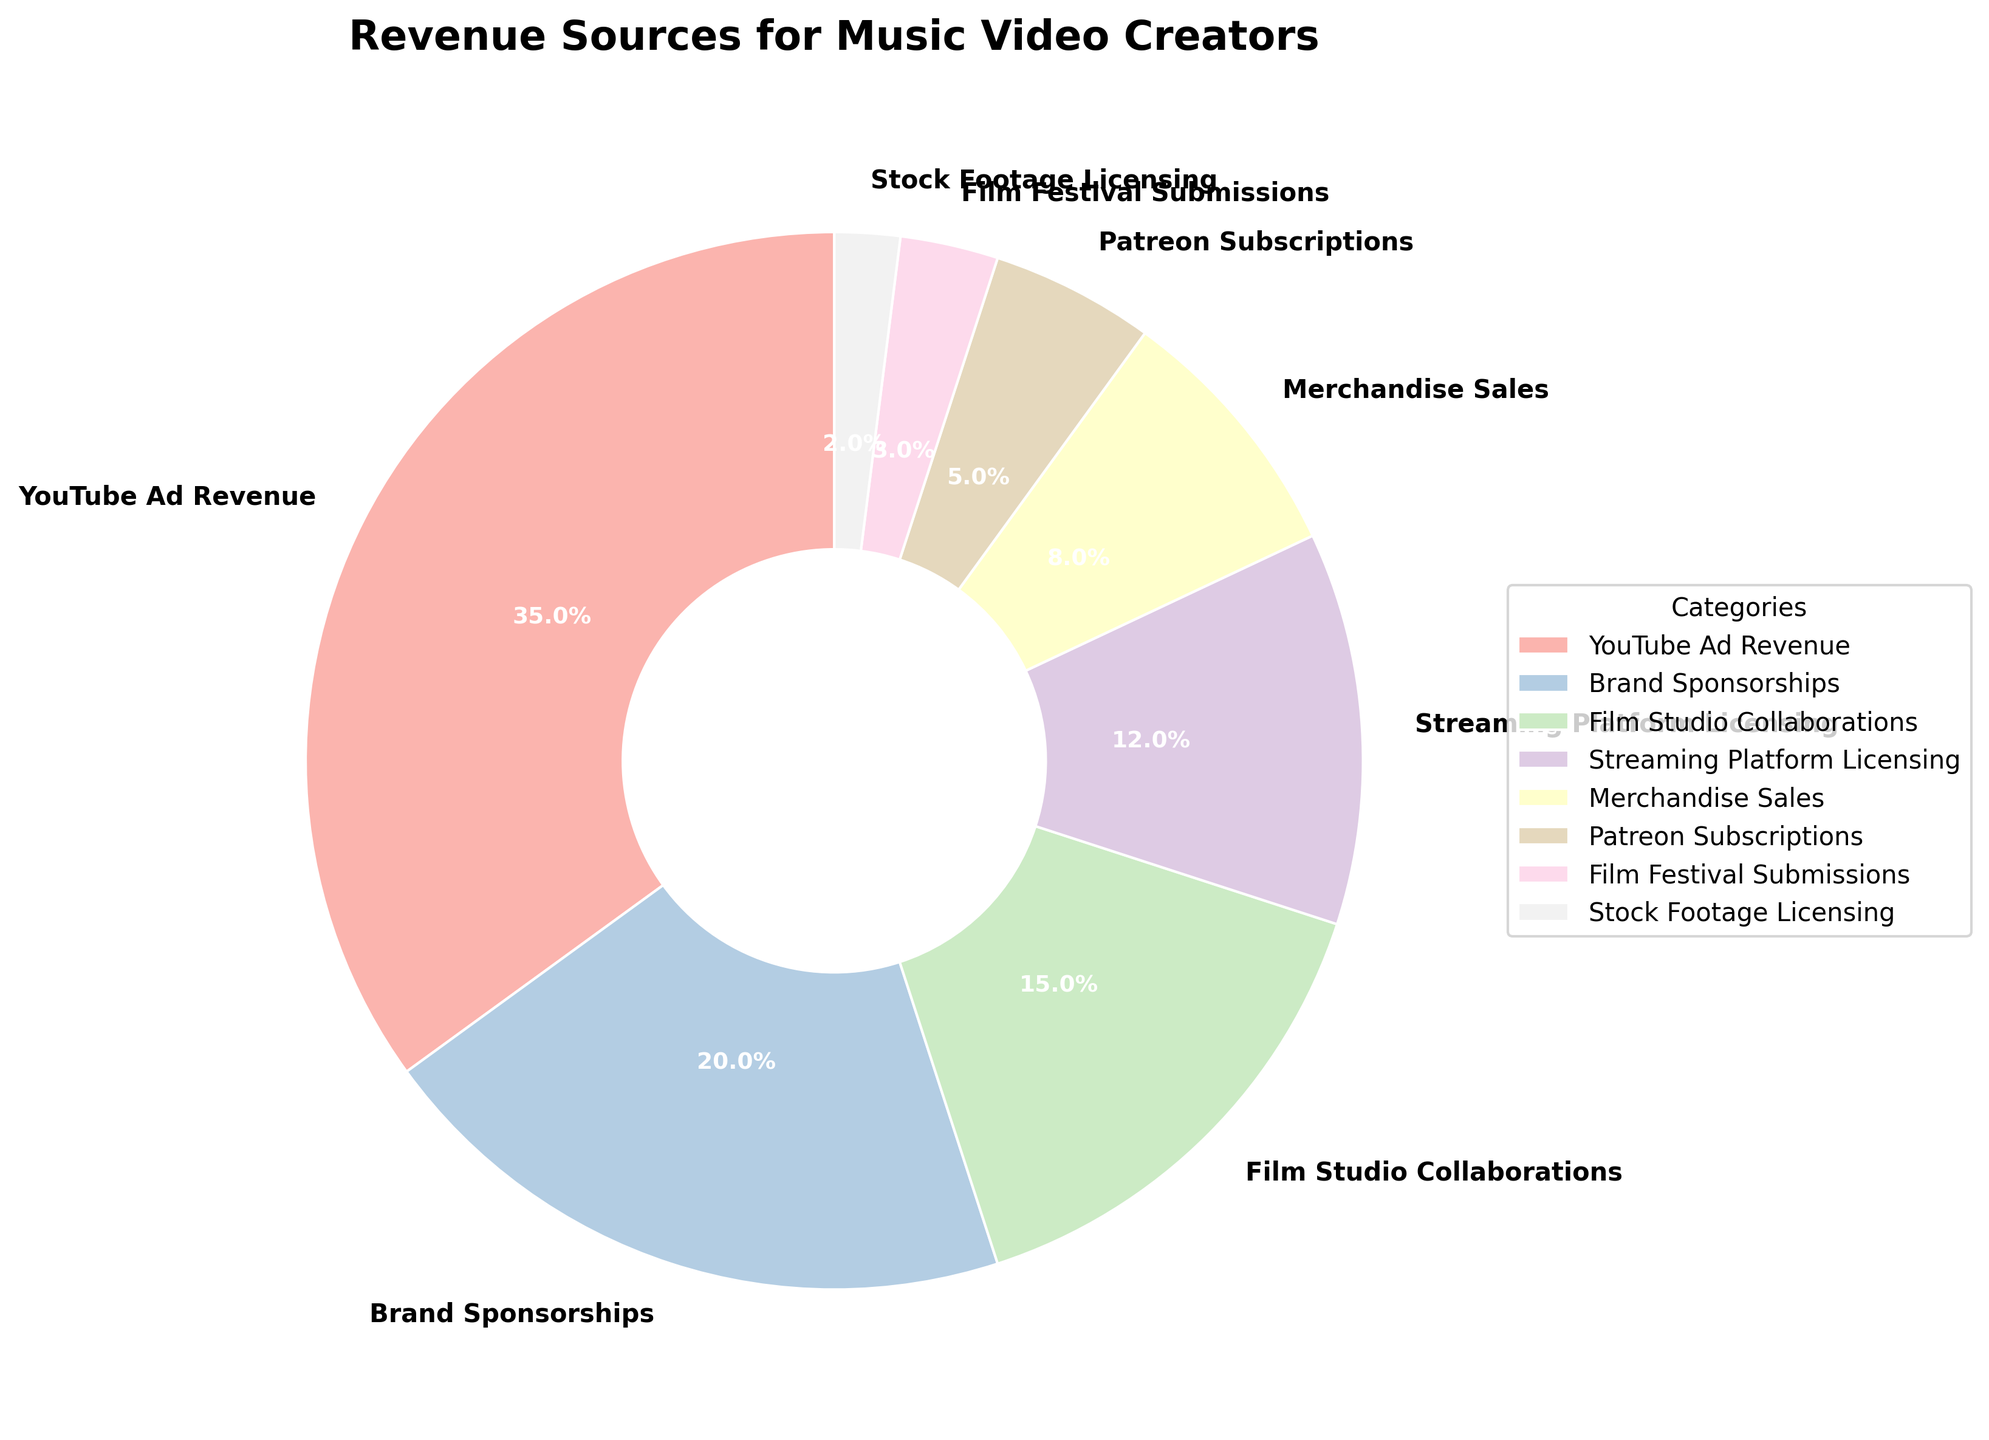What is the largest revenue source for music video creators? By visually inspecting the pie chart, the largest slice corresponds to "YouTube Ad Revenue," with 35% clearly marked.
Answer: YouTube Ad Revenue What is the combined percentage of revenue from Brand Sponsorships and Film Studio Collaborations? Add the percentages directly from the pie chart: 20% (Brand Sponsorships) + 15% (Film Studio Collaborations) = 35%.
Answer: 35% Which revenue source contributes the least? By looking at the smallest slice in the pie chart, "Stock Footage Licensing" has the smallest percentage, 2%.
Answer: Stock Footage Licensing How does the revenue from Streaming Platform Licensing compare to Merchandise Sales? Streaming Platform Licensing is visually represented with a larger slice than Merchandise Sales. The percentages are 12% and 8% respectively, showing Streaming Platform Licensing contributes more.
Answer: Streaming Platform Licensing > Merchandise Sales If we combine the revenue percentages from Patreon Subscriptions and Film Festival Submissions, which other single revenue source would they exceed? Sum the percentages of Patreon Subscriptions and Film Festival Submissions: 5% + 3% = 8%. Compare it to other sources, and it exactly matches Merchandise Sales, so it does not exceed it but equals it.
Answer: Merchandise Sales (equal) What proportion of revenue comes from non-advertising sources? Sum up all non-advertising sources excluding "YouTube Ad Revenue": 20% (Brand Sponsorships) + 15% (Film Studio Collaborations) + 12% (Streaming Platform Licensing) + 8% (Merchandise Sales) + 5% (Patreon Subscriptions) + 3% (Film Festival Submissions) + 2% (Stock Footage Licensing) = 65%.
Answer: 65% Which revenue sources are less than 10%? Visually, the slices that are less than 10% include Merchandise Sales (8%), Patreon Subscriptions (5%), Film Festival Submissions (3%), and Stock Footage Licensing (2%).
Answer: Merchandise Sales, Patreon Subscriptions, Film Festival Submissions, Stock Footage Licensing Is the sum of the percentages for Brand Sponsorships and Streaming Platform Licensing greater than YouTube Ad Revenue? Sum the percentages of Brand Sponsorships and Streaming Platform Licensing: 20% + 12% = 32%. Compare it to YouTube Ad Revenue, which is 35%. Since 32% is less than 35%, it is not greater.
Answer: No What is the difference in percentage between YouTube Ad Revenue and Film Studio Collaborations? Subtract the percentage of Film Studio Collaborations from YouTube Ad Revenue: 35% - 15% = 20%.
Answer: 20% 